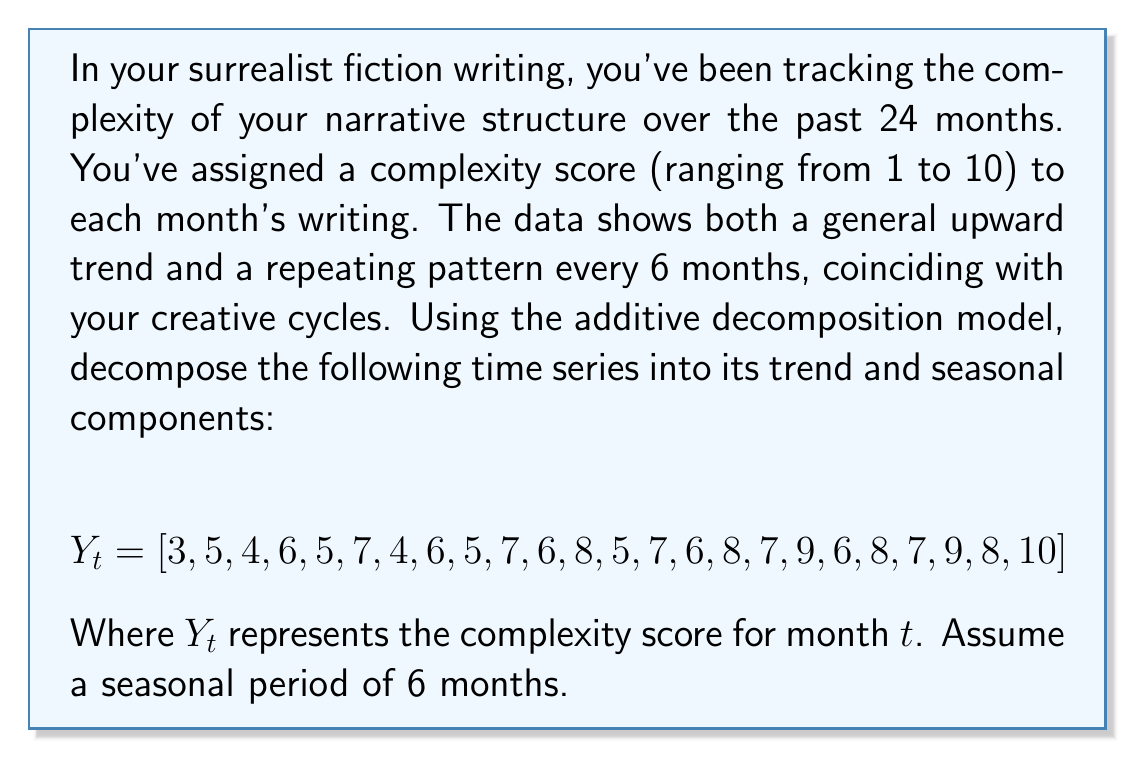Give your solution to this math problem. To decompose this time series, we'll use the additive model:

$$Y_t = T_t + S_t + E_t$$

Where $T_t$ is the trend component, $S_t$ is the seasonal component, and $E_t$ is the residual (which we'll ignore for this analysis).

Step 1: Calculate the centered moving average (CMA) to estimate the trend.
For a 6-month seasonality, we'll use a 6-month moving average, then center it:

$$CMA_t = \frac{1}{6}(Y_{t-3} + Y_{t-2} + Y_{t-1} + Y_t + Y_{t+1} + Y_{t+2})$$

Calculating this for all possible points gives us:

$$T_t = [-, -, -, 5.0, 5.17, 5.33, 5.5, 5.67, 5.83, 6.0, 6.17, 6.33, 6.5, 6.67, 6.83, 7.0, 7.17, 7.33, 7.5, 7.67, -, -, -, -]$$

Step 2: Detrend the series by subtracting the trend from the original data:

$$Y_t - T_t = S_t + E_t$$

Step 3: Estimate the seasonal component by averaging the detrended values for each season (month position in the cycle):

Month 1: $(-2, -1.5, -1.5, -1.5) \rightarrow -1.625$
Month 2: $(-, 0.33, 0.33, 0.33) \rightarrow 0.33$
Month 3: $(-, -1.83, -0.83, -0.83) \rightarrow -1.16$
Month 4: $(1, 0.33, 1, 0.33) \rightarrow 0.67$
Month 5: $(-0.17, -0.17, 0.17, -0.67) \rightarrow -0.21$
Month 6: $(1.67, 1.67, 1.67, -) \rightarrow 1.67$

Step 4: Normalize the seasonal component so it sums to zero:

Mean of seasonal components: $(-1.625 + 0.33 - 1.16 + 0.67 - 0.21 + 1.67) / 6 = -0.054$

Subtract this mean from each component:

$$S_t = [-1.57, 0.38, -1.11, 0.72, -0.16, 1.72]$$

This pattern repeats every 6 months.

Step 5: The final trend component is the original CMA, and the seasonal component is the normalized values repeating every 6 months.
Answer: Trend component (T_t):
$$T_t = [-, -, -, 5.0, 5.17, 5.33, 5.5, 5.67, 5.83, 6.0, 6.17, 6.33, 6.5, 6.67, 6.83, 7.0, 7.17, 7.33, 7.5, 7.67, -, -, -, -]$$

Seasonal component (S_t), repeating every 6 months:
$$S_t = [-1.57, 0.38, -1.11, 0.72, -0.16, 1.72]$$ 